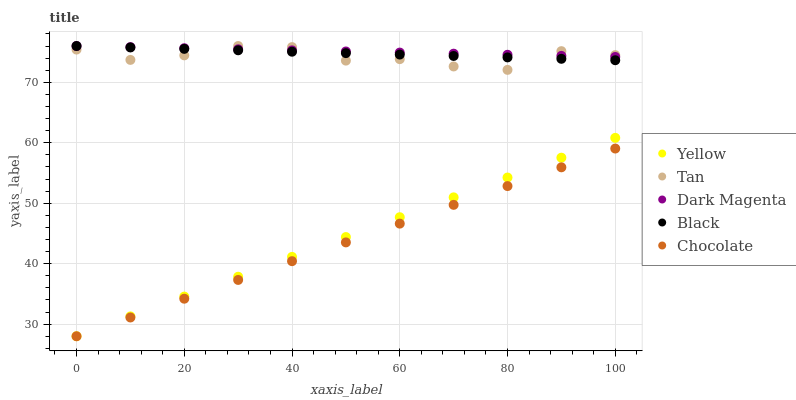Does Chocolate have the minimum area under the curve?
Answer yes or no. Yes. Does Dark Magenta have the maximum area under the curve?
Answer yes or no. Yes. Does Black have the minimum area under the curve?
Answer yes or no. No. Does Black have the maximum area under the curve?
Answer yes or no. No. Is Yellow the smoothest?
Answer yes or no. Yes. Is Tan the roughest?
Answer yes or no. Yes. Is Black the smoothest?
Answer yes or no. No. Is Black the roughest?
Answer yes or no. No. Does Yellow have the lowest value?
Answer yes or no. Yes. Does Black have the lowest value?
Answer yes or no. No. Does Dark Magenta have the highest value?
Answer yes or no. Yes. Does Yellow have the highest value?
Answer yes or no. No. Is Chocolate less than Dark Magenta?
Answer yes or no. Yes. Is Tan greater than Yellow?
Answer yes or no. Yes. Does Black intersect Tan?
Answer yes or no. Yes. Is Black less than Tan?
Answer yes or no. No. Is Black greater than Tan?
Answer yes or no. No. Does Chocolate intersect Dark Magenta?
Answer yes or no. No. 